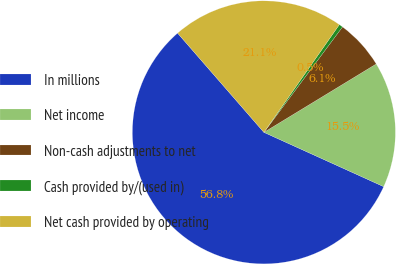Convert chart to OTSL. <chart><loc_0><loc_0><loc_500><loc_500><pie_chart><fcel>In millions<fcel>Net income<fcel>Non-cash adjustments to net<fcel>Cash provided by/(used in)<fcel>Net cash provided by operating<nl><fcel>56.83%<fcel>15.48%<fcel>6.1%<fcel>0.47%<fcel>21.12%<nl></chart> 